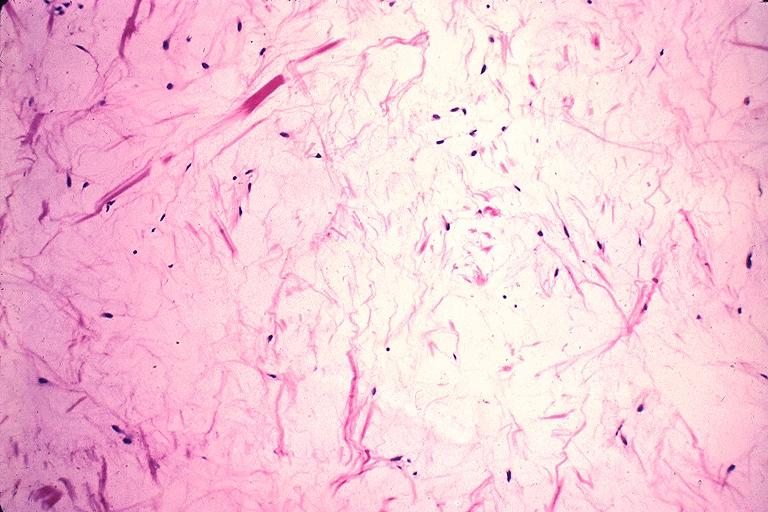s oral present?
Answer the question using a single word or phrase. Yes 